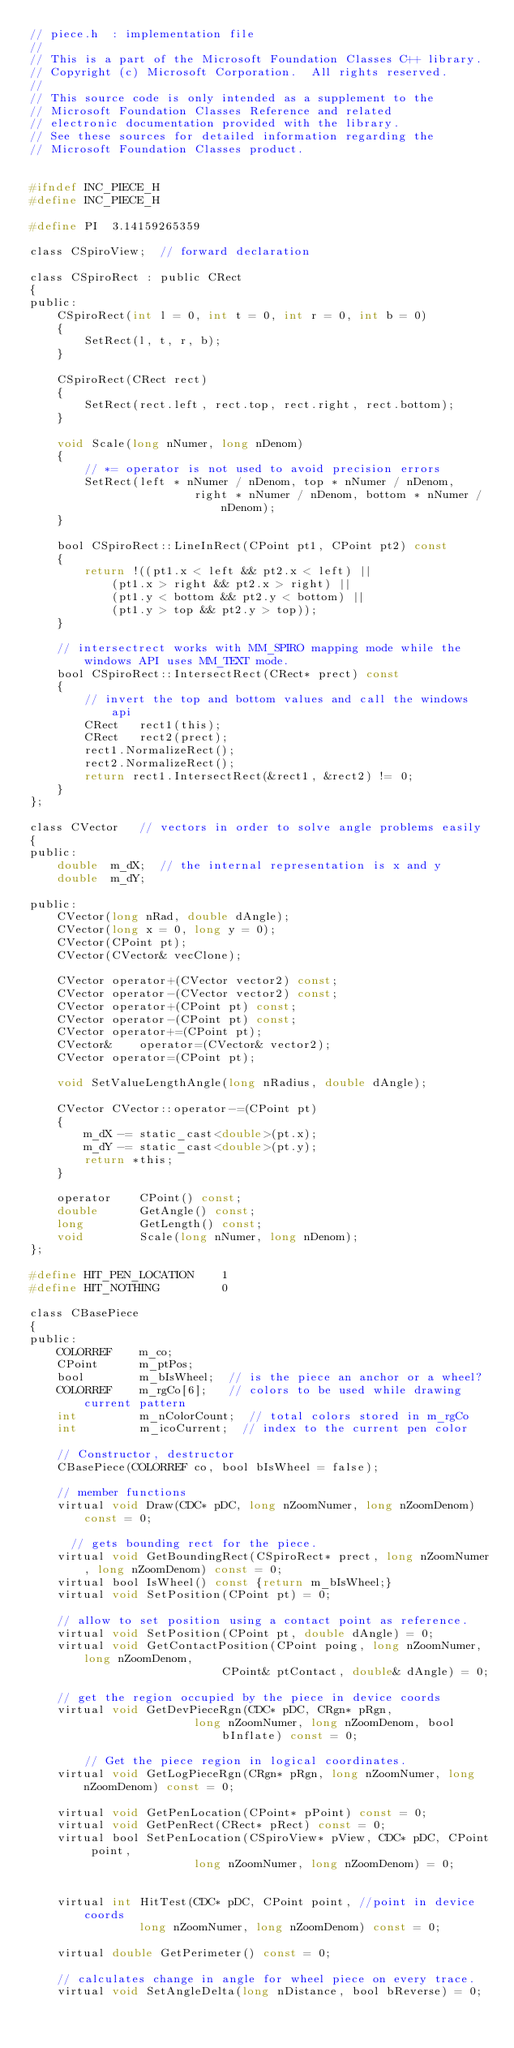<code> <loc_0><loc_0><loc_500><loc_500><_C_>// piece.h  : implementation file
//
// This is a part of the Microsoft Foundation Classes C++ library.
// Copyright (c) Microsoft Corporation.  All rights reserved.
//
// This source code is only intended as a supplement to the
// Microsoft Foundation Classes Reference and related
// electronic documentation provided with the library.
// See these sources for detailed information regarding the
// Microsoft Foundation Classes product.


#ifndef INC_PIECE_H
#define INC_PIECE_H

#define PI	3.14159265359

class CSpiroView;  // forward declaration

class CSpiroRect : public CRect
{
public:
	CSpiroRect(int l = 0, int t = 0, int r = 0, int b = 0)
	{
		SetRect(l, t, r, b);
	}

	CSpiroRect(CRect rect)
	{
		SetRect(rect.left, rect.top, rect.right, rect.bottom);
	}

	void Scale(long nNumer, long nDenom)
	{
		// *= operator is not used to avoid precision errors
		SetRect(left * nNumer / nDenom, top * nNumer / nDenom,
						right * nNumer / nDenom, bottom * nNumer / nDenom);
	}

	bool CSpiroRect::LineInRect(CPoint pt1, CPoint pt2) const
	{
		return !((pt1.x < left && pt2.x < left) || 
			(pt1.x > right && pt2.x > right) ||
			(pt1.y < bottom && pt2.y < bottom) ||
			(pt1.y > top && pt2.y > top));
	}

	// intersectrect works with MM_SPIRO mapping mode while the windows API uses MM_TEXT mode.
	bool CSpiroRect::IntersectRect(CRect* prect) const
	{
		// invert the top and bottom values and call the windows api
		CRect	rect1(this);
		CRect	rect2(prect);
		rect1.NormalizeRect();
		rect2.NormalizeRect();
		return rect1.IntersectRect(&rect1, &rect2) != 0;
	}
};

class CVector   // vectors in order to solve angle problems easily
{
public:
	double	m_dX;  // the internal representation is x and y
	double	m_dY;

public:
	CVector(long nRad, double dAngle);
	CVector(long x = 0, long y = 0);
	CVector(CPoint pt);
	CVector(CVector& vecClone);

	CVector	operator+(CVector vector2) const;
	CVector	operator-(CVector vector2) const;
	CVector	operator+(CPoint pt) const;
	CVector	operator-(CPoint pt) const;
	CVector	operator+=(CPoint pt);
	CVector&	operator=(CVector& vector2);
	CVector	operator=(CPoint pt);
	
	void SetValueLengthAngle(long nRadius, double dAngle);

	CVector CVector::operator-=(CPoint pt)
	{
		m_dX -= static_cast<double>(pt.x);
		m_dY -= static_cast<double>(pt.y);
		return *this;
	}

	operator	CPoint() const;
	double		GetAngle() const;
	long		GetLength() const;
	void		Scale(long nNumer, long nDenom);
};

#define HIT_PEN_LOCATION	1
#define HIT_NOTHING			0

class CBasePiece
{
public:
	COLORREF	m_co;
	CPoint		m_ptPos;
	bool		m_bIsWheel;  // is the piece an anchor or a wheel?
	COLORREF	m_rgCo[6];   // colors to be used while drawing current pattern
	int			m_nColorCount;  // total colors stored in m_rgCo
	int			m_icoCurrent;  // index to the current pen color 

	// Constructor, destructor
	CBasePiece(COLORREF co, bool bIsWheel = false);

	// member functions
	virtual void Draw(CDC* pDC, long nZoomNumer, long nZoomDenom) const = 0;

	  // gets bounding rect for the piece.
	virtual void GetBoundingRect(CSpiroRect* prect, long nZoomNumer, long nZoomDenom) const = 0;
	virtual bool IsWheel() const {return m_bIsWheel;}
	virtual void SetPosition(CPoint pt) = 0;

	// allow to set position using a contact point as reference.
	virtual void SetPosition(CPoint pt, double dAngle) = 0;
	virtual void GetContactPosition(CPoint poing, long nZoomNumer, long nZoomDenom,
							CPoint& ptContact, double& dAngle) = 0;

	// get the region occupied by the piece in device coords
	virtual void GetDevPieceRgn(CDC* pDC, CRgn* pRgn, 
						long nZoomNumer, long nZoomDenom, bool bInflate) const = 0;

		// Get the piece region in logical coordinates.
	virtual void GetLogPieceRgn(CRgn* pRgn, long nZoomNumer, long nZoomDenom) const = 0;

	virtual void GetPenLocation(CPoint* pPoint) const = 0;
	virtual void GetPenRect(CRect* pRect) const = 0;
	virtual bool SetPenLocation(CSpiroView* pView, CDC* pDC, CPoint point, 
						long nZoomNumer, long nZoomDenom) = 0;


	virtual int HitTest(CDC* pDC, CPoint point, //point in device coords
				long nZoomNumer, long nZoomDenom) const = 0; 

	virtual double GetPerimeter() const = 0;

	// calculates change in angle for wheel piece on every trace.
	virtual void SetAngleDelta(long nDistance, bool bReverse) = 0;
</code> 